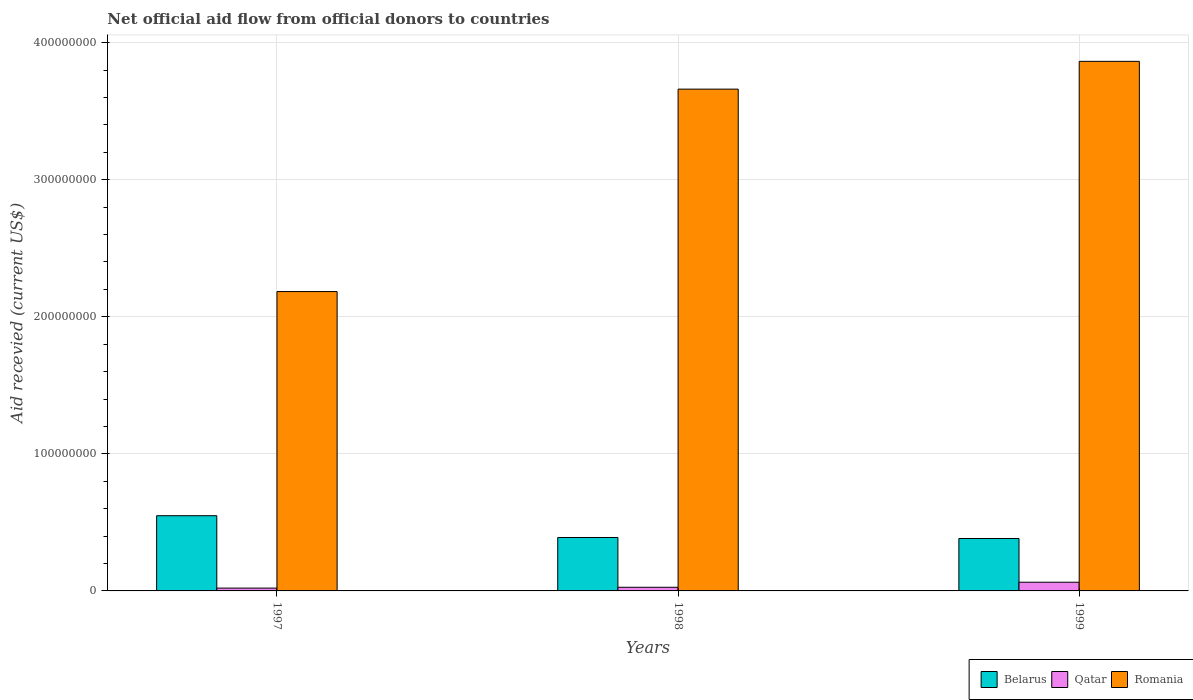How many different coloured bars are there?
Your response must be concise. 3. Are the number of bars on each tick of the X-axis equal?
Ensure brevity in your answer.  Yes. In how many cases, is the number of bars for a given year not equal to the number of legend labels?
Make the answer very short. 0. What is the total aid received in Belarus in 1998?
Make the answer very short. 3.90e+07. Across all years, what is the maximum total aid received in Belarus?
Offer a terse response. 5.49e+07. Across all years, what is the minimum total aid received in Belarus?
Provide a succinct answer. 3.82e+07. In which year was the total aid received in Qatar minimum?
Provide a short and direct response. 1997. What is the total total aid received in Belarus in the graph?
Keep it short and to the point. 1.32e+08. What is the difference between the total aid received in Romania in 1997 and that in 1998?
Make the answer very short. -1.48e+08. What is the difference between the total aid received in Belarus in 1998 and the total aid received in Romania in 1999?
Offer a very short reply. -3.47e+08. What is the average total aid received in Romania per year?
Give a very brief answer. 3.24e+08. In the year 1999, what is the difference between the total aid received in Romania and total aid received in Belarus?
Make the answer very short. 3.48e+08. What is the ratio of the total aid received in Qatar in 1997 to that in 1999?
Your response must be concise. 0.32. Is the total aid received in Romania in 1997 less than that in 1999?
Keep it short and to the point. Yes. What is the difference between the highest and the second highest total aid received in Romania?
Offer a very short reply. 2.03e+07. What is the difference between the highest and the lowest total aid received in Romania?
Your answer should be very brief. 1.68e+08. Is the sum of the total aid received in Romania in 1997 and 1999 greater than the maximum total aid received in Qatar across all years?
Provide a succinct answer. Yes. What does the 3rd bar from the left in 1998 represents?
Provide a succinct answer. Romania. What does the 3rd bar from the right in 1997 represents?
Ensure brevity in your answer.  Belarus. How many bars are there?
Your answer should be very brief. 9. What is the difference between two consecutive major ticks on the Y-axis?
Keep it short and to the point. 1.00e+08. Are the values on the major ticks of Y-axis written in scientific E-notation?
Provide a succinct answer. No. How many legend labels are there?
Your answer should be very brief. 3. What is the title of the graph?
Provide a succinct answer. Net official aid flow from official donors to countries. Does "Hungary" appear as one of the legend labels in the graph?
Offer a very short reply. No. What is the label or title of the X-axis?
Offer a terse response. Years. What is the label or title of the Y-axis?
Make the answer very short. Aid recevied (current US$). What is the Aid recevied (current US$) in Belarus in 1997?
Your answer should be very brief. 5.49e+07. What is the Aid recevied (current US$) in Qatar in 1997?
Provide a short and direct response. 2.06e+06. What is the Aid recevied (current US$) of Romania in 1997?
Provide a short and direct response. 2.18e+08. What is the Aid recevied (current US$) of Belarus in 1998?
Your answer should be compact. 3.90e+07. What is the Aid recevied (current US$) of Qatar in 1998?
Your answer should be very brief. 2.66e+06. What is the Aid recevied (current US$) of Romania in 1998?
Provide a succinct answer. 3.66e+08. What is the Aid recevied (current US$) in Belarus in 1999?
Give a very brief answer. 3.82e+07. What is the Aid recevied (current US$) in Qatar in 1999?
Keep it short and to the point. 6.34e+06. What is the Aid recevied (current US$) of Romania in 1999?
Provide a succinct answer. 3.86e+08. Across all years, what is the maximum Aid recevied (current US$) in Belarus?
Provide a short and direct response. 5.49e+07. Across all years, what is the maximum Aid recevied (current US$) of Qatar?
Ensure brevity in your answer.  6.34e+06. Across all years, what is the maximum Aid recevied (current US$) of Romania?
Offer a very short reply. 3.86e+08. Across all years, what is the minimum Aid recevied (current US$) in Belarus?
Make the answer very short. 3.82e+07. Across all years, what is the minimum Aid recevied (current US$) of Qatar?
Make the answer very short. 2.06e+06. Across all years, what is the minimum Aid recevied (current US$) in Romania?
Offer a terse response. 2.18e+08. What is the total Aid recevied (current US$) of Belarus in the graph?
Your answer should be compact. 1.32e+08. What is the total Aid recevied (current US$) of Qatar in the graph?
Offer a terse response. 1.11e+07. What is the total Aid recevied (current US$) in Romania in the graph?
Offer a terse response. 9.71e+08. What is the difference between the Aid recevied (current US$) of Belarus in 1997 and that in 1998?
Provide a succinct answer. 1.59e+07. What is the difference between the Aid recevied (current US$) in Qatar in 1997 and that in 1998?
Keep it short and to the point. -6.00e+05. What is the difference between the Aid recevied (current US$) in Romania in 1997 and that in 1998?
Your response must be concise. -1.48e+08. What is the difference between the Aid recevied (current US$) of Belarus in 1997 and that in 1999?
Provide a short and direct response. 1.66e+07. What is the difference between the Aid recevied (current US$) of Qatar in 1997 and that in 1999?
Give a very brief answer. -4.28e+06. What is the difference between the Aid recevied (current US$) of Romania in 1997 and that in 1999?
Give a very brief answer. -1.68e+08. What is the difference between the Aid recevied (current US$) in Belarus in 1998 and that in 1999?
Keep it short and to the point. 7.30e+05. What is the difference between the Aid recevied (current US$) of Qatar in 1998 and that in 1999?
Ensure brevity in your answer.  -3.68e+06. What is the difference between the Aid recevied (current US$) of Romania in 1998 and that in 1999?
Your answer should be compact. -2.03e+07. What is the difference between the Aid recevied (current US$) in Belarus in 1997 and the Aid recevied (current US$) in Qatar in 1998?
Ensure brevity in your answer.  5.22e+07. What is the difference between the Aid recevied (current US$) of Belarus in 1997 and the Aid recevied (current US$) of Romania in 1998?
Your answer should be compact. -3.11e+08. What is the difference between the Aid recevied (current US$) in Qatar in 1997 and the Aid recevied (current US$) in Romania in 1998?
Give a very brief answer. -3.64e+08. What is the difference between the Aid recevied (current US$) in Belarus in 1997 and the Aid recevied (current US$) in Qatar in 1999?
Ensure brevity in your answer.  4.85e+07. What is the difference between the Aid recevied (current US$) of Belarus in 1997 and the Aid recevied (current US$) of Romania in 1999?
Provide a succinct answer. -3.32e+08. What is the difference between the Aid recevied (current US$) of Qatar in 1997 and the Aid recevied (current US$) of Romania in 1999?
Ensure brevity in your answer.  -3.84e+08. What is the difference between the Aid recevied (current US$) of Belarus in 1998 and the Aid recevied (current US$) of Qatar in 1999?
Keep it short and to the point. 3.26e+07. What is the difference between the Aid recevied (current US$) of Belarus in 1998 and the Aid recevied (current US$) of Romania in 1999?
Provide a succinct answer. -3.47e+08. What is the difference between the Aid recevied (current US$) in Qatar in 1998 and the Aid recevied (current US$) in Romania in 1999?
Make the answer very short. -3.84e+08. What is the average Aid recevied (current US$) in Belarus per year?
Provide a succinct answer. 4.40e+07. What is the average Aid recevied (current US$) in Qatar per year?
Your answer should be very brief. 3.69e+06. What is the average Aid recevied (current US$) in Romania per year?
Provide a succinct answer. 3.24e+08. In the year 1997, what is the difference between the Aid recevied (current US$) of Belarus and Aid recevied (current US$) of Qatar?
Your answer should be very brief. 5.28e+07. In the year 1997, what is the difference between the Aid recevied (current US$) in Belarus and Aid recevied (current US$) in Romania?
Keep it short and to the point. -1.64e+08. In the year 1997, what is the difference between the Aid recevied (current US$) of Qatar and Aid recevied (current US$) of Romania?
Keep it short and to the point. -2.16e+08. In the year 1998, what is the difference between the Aid recevied (current US$) in Belarus and Aid recevied (current US$) in Qatar?
Offer a terse response. 3.63e+07. In the year 1998, what is the difference between the Aid recevied (current US$) of Belarus and Aid recevied (current US$) of Romania?
Make the answer very short. -3.27e+08. In the year 1998, what is the difference between the Aid recevied (current US$) of Qatar and Aid recevied (current US$) of Romania?
Ensure brevity in your answer.  -3.63e+08. In the year 1999, what is the difference between the Aid recevied (current US$) in Belarus and Aid recevied (current US$) in Qatar?
Offer a terse response. 3.19e+07. In the year 1999, what is the difference between the Aid recevied (current US$) in Belarus and Aid recevied (current US$) in Romania?
Make the answer very short. -3.48e+08. In the year 1999, what is the difference between the Aid recevied (current US$) of Qatar and Aid recevied (current US$) of Romania?
Give a very brief answer. -3.80e+08. What is the ratio of the Aid recevied (current US$) of Belarus in 1997 to that in 1998?
Your answer should be very brief. 1.41. What is the ratio of the Aid recevied (current US$) in Qatar in 1997 to that in 1998?
Your answer should be compact. 0.77. What is the ratio of the Aid recevied (current US$) of Romania in 1997 to that in 1998?
Ensure brevity in your answer.  0.6. What is the ratio of the Aid recevied (current US$) of Belarus in 1997 to that in 1999?
Provide a succinct answer. 1.43. What is the ratio of the Aid recevied (current US$) of Qatar in 1997 to that in 1999?
Offer a terse response. 0.32. What is the ratio of the Aid recevied (current US$) of Romania in 1997 to that in 1999?
Your response must be concise. 0.57. What is the ratio of the Aid recevied (current US$) in Belarus in 1998 to that in 1999?
Offer a very short reply. 1.02. What is the ratio of the Aid recevied (current US$) of Qatar in 1998 to that in 1999?
Offer a terse response. 0.42. What is the ratio of the Aid recevied (current US$) of Romania in 1998 to that in 1999?
Keep it short and to the point. 0.95. What is the difference between the highest and the second highest Aid recevied (current US$) in Belarus?
Your answer should be very brief. 1.59e+07. What is the difference between the highest and the second highest Aid recevied (current US$) in Qatar?
Give a very brief answer. 3.68e+06. What is the difference between the highest and the second highest Aid recevied (current US$) in Romania?
Ensure brevity in your answer.  2.03e+07. What is the difference between the highest and the lowest Aid recevied (current US$) in Belarus?
Your answer should be very brief. 1.66e+07. What is the difference between the highest and the lowest Aid recevied (current US$) of Qatar?
Your response must be concise. 4.28e+06. What is the difference between the highest and the lowest Aid recevied (current US$) of Romania?
Keep it short and to the point. 1.68e+08. 